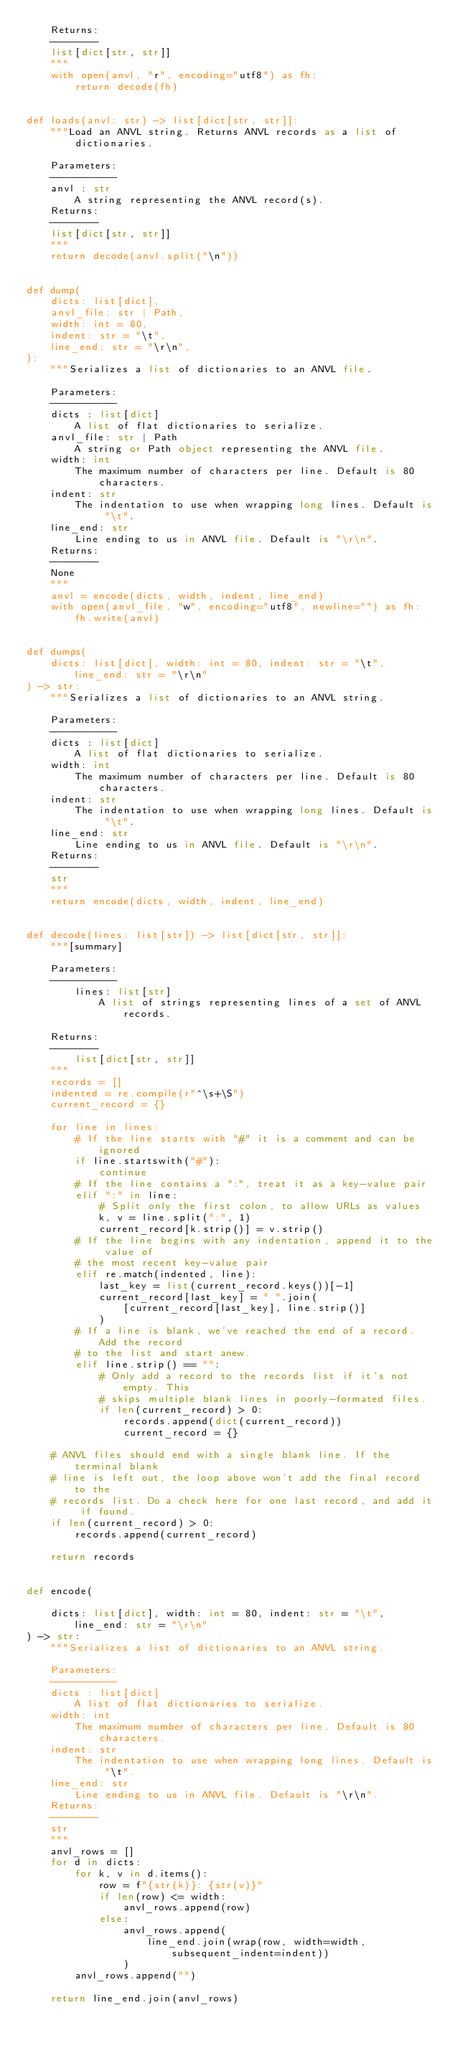<code> <loc_0><loc_0><loc_500><loc_500><_Python_>    Returns:
    --------
    list[dict[str, str]]
    """
    with open(anvl, "r", encoding="utf8") as fh:
        return decode(fh)


def loads(anvl: str) -> list[dict[str, str]]:
    """Load an ANVL string. Returns ANVL records as a list of dictionaries.
    
    Parameters:
    -----------
    anvl : str
        A string representing the ANVL record(s).
    Returns:
    --------
    list[dict[str, str]]
    """
    return decode(anvl.split("\n"))


def dump(
    dicts: list[dict],
    anvl_file: str | Path,
    width: int = 80,
    indent: str = "\t",
    line_end: str = "\r\n",
):
    """Serializes a list of dictionaries to an ANVL file.
    
    Parameters:
    -----------
    dicts : list[dict]
        A list of flat dictionaries to serialize.
    anvl_file: str | Path
        A string or Path object representing the ANVL file.
    width: int
        The maximum number of characters per line. Default is 80 characters.
    indent: str
        The indentation to use when wrapping long lines. Default is "\t".
    line_end: str
        Line ending to us in ANVL file. Default is "\r\n".
    Returns:
    --------
    None
    """
    anvl = encode(dicts, width, indent, line_end)
    with open(anvl_file, "w", encoding="utf8", newline="") as fh:
        fh.write(anvl)


def dumps(
    dicts: list[dict], width: int = 80, indent: str = "\t", line_end: str = "\r\n"
) -> str:
    """Serializes a list of dictionaries to an ANVL string.
    
    Parameters:
    -----------
    dicts : list[dict]
        A list of flat dictionaries to serialize.
    width: int
        The maximum number of characters per line. Default is 80 characters.
    indent: str
        The indentation to use when wrapping long lines. Default is "\t".
    line_end: str
        Line ending to us in ANVL file. Default is "\r\n".
    Returns:
    --------
    str
    """
    return encode(dicts, width, indent, line_end)


def decode(lines: list[str]) -> list[dict[str, str]]:
    """[summary]

    Parameters:
    -----------
        lines: list[str]
            A list of strings representing lines of a set of ANVL records.

    Returns:
    --------
        list[dict[str, str]]
    """
    records = []
    indented = re.compile(r"^\s+\S")
    current_record = {}

    for line in lines:
        # If the line starts with "#" it is a comment and can be  ignored
        if line.startswith("#"):
            continue
        # If the line contains a ":", treat it as a key-value pair
        elif ":" in line:
            # Split only the first colon, to allow URLs as values
            k, v = line.split(":", 1)
            current_record[k.strip()] = v.strip()
        # If the line begins with any indentation, append it to the value of
        # the most recent key-value pair
        elif re.match(indented, line):
            last_key = list(current_record.keys())[-1]
            current_record[last_key] = " ".join(
                [current_record[last_key], line.strip()]
            )
        # If a line is blank, we've reached the end of a record. Add the record
        # to the list and start anew.
        elif line.strip() == "":
            # Only add a record to the records list if it's not empty. This
            # skips multiple blank lines in poorly-formated files.
            if len(current_record) > 0:
                records.append(dict(current_record))
                current_record = {}

    # ANVL files should end with a single blank line. If the terminal blank
    # line is left out, the loop above won't add the final record to the
    # records list. Do a check here for one last record, and add it if found.
    if len(current_record) > 0:
        records.append(current_record)

    return records


def encode(
    
    dicts: list[dict], width: int = 80, indent: str = "\t", line_end: str = "\r\n"
) -> str:
    """Serializes a list of dictionaries to an ANVL string.
    
    Parameters:
    -----------
    dicts : list[dict]
        A list of flat dictionaries to serialize.
    width: int
        The maximum number of characters per line. Default is 80 characters.
    indent: str
        The indentation to use when wrapping long lines. Default is "\t".
    line_end: str
        Line ending to us in ANVL file. Default is "\r\n".
    Returns:
    --------
    str
    """
    anvl_rows = []
    for d in dicts:
        for k, v in d.items():
            row = f"{str(k)}: {str(v)}"
            if len(row) <= width:
                anvl_rows.append(row)
            else:
                anvl_rows.append(
                    line_end.join(wrap(row, width=width, subsequent_indent=indent))
                )
        anvl_rows.append("")

    return line_end.join(anvl_rows)
</code> 